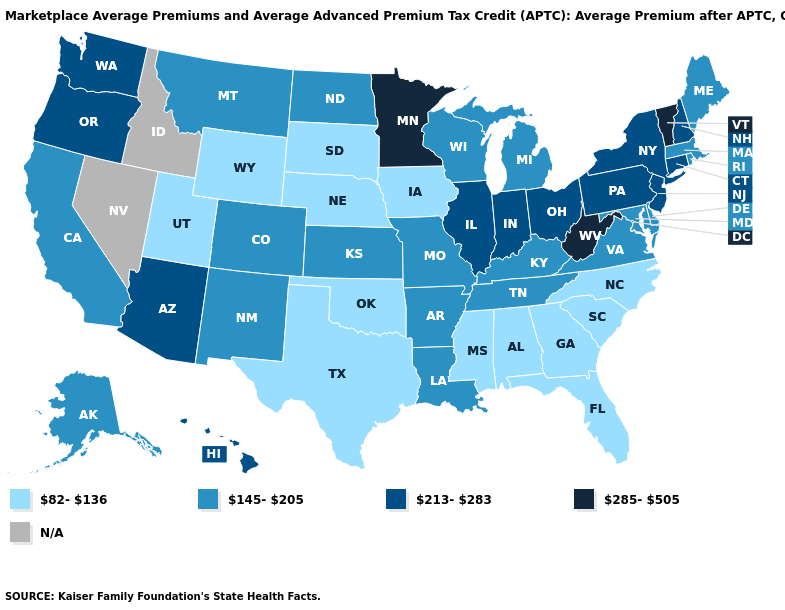Does the first symbol in the legend represent the smallest category?
Give a very brief answer. Yes. Name the states that have a value in the range 82-136?
Short answer required. Alabama, Florida, Georgia, Iowa, Mississippi, Nebraska, North Carolina, Oklahoma, South Carolina, South Dakota, Texas, Utah, Wyoming. What is the value of Arkansas?
Quick response, please. 145-205. Which states have the lowest value in the USA?
Keep it brief. Alabama, Florida, Georgia, Iowa, Mississippi, Nebraska, North Carolina, Oklahoma, South Carolina, South Dakota, Texas, Utah, Wyoming. What is the value of Virginia?
Write a very short answer. 145-205. Is the legend a continuous bar?
Give a very brief answer. No. Among the states that border Oklahoma , which have the highest value?
Be succinct. Arkansas, Colorado, Kansas, Missouri, New Mexico. Name the states that have a value in the range 213-283?
Write a very short answer. Arizona, Connecticut, Hawaii, Illinois, Indiana, New Hampshire, New Jersey, New York, Ohio, Oregon, Pennsylvania, Washington. Name the states that have a value in the range N/A?
Short answer required. Idaho, Nevada. Which states have the highest value in the USA?
Concise answer only. Minnesota, Vermont, West Virginia. Does West Virginia have the highest value in the USA?
Answer briefly. Yes. What is the value of Colorado?
Be succinct. 145-205. What is the value of Pennsylvania?
Write a very short answer. 213-283. 